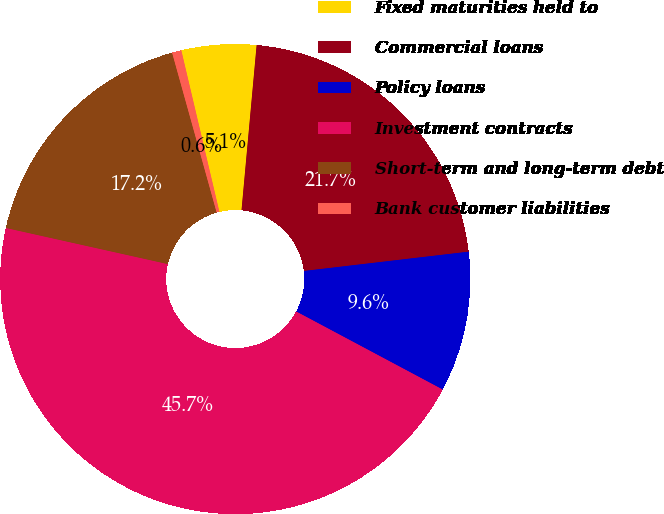<chart> <loc_0><loc_0><loc_500><loc_500><pie_chart><fcel>Fixed maturities held to<fcel>Commercial loans<fcel>Policy loans<fcel>Investment contracts<fcel>Short-term and long-term debt<fcel>Bank customer liabilities<nl><fcel>5.14%<fcel>21.69%<fcel>9.65%<fcel>45.7%<fcel>17.18%<fcel>0.64%<nl></chart> 